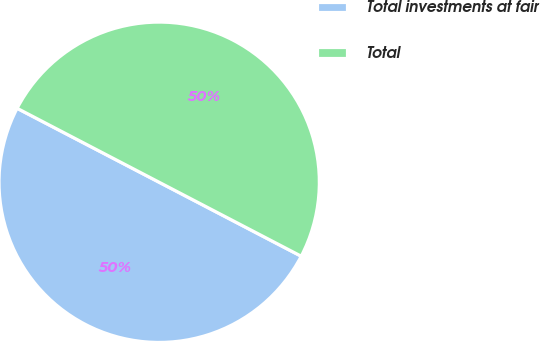Convert chart to OTSL. <chart><loc_0><loc_0><loc_500><loc_500><pie_chart><fcel>Total investments at fair<fcel>Total<nl><fcel>50.0%<fcel>50.0%<nl></chart> 